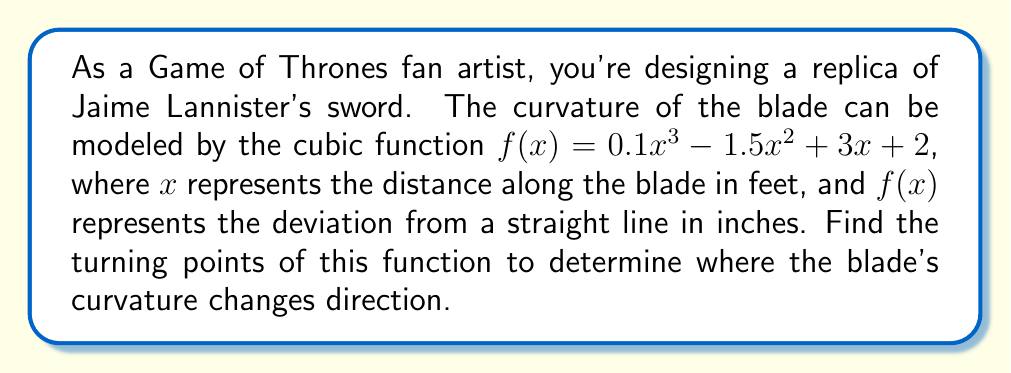What is the answer to this math problem? To find the turning points of a cubic function, we need to follow these steps:

1) The turning points occur where the derivative of the function is zero. Let's find the derivative:

   $f'(x) = 0.3x^2 - 3x + 3$

2) Set the derivative equal to zero and solve for x:

   $0.3x^2 - 3x + 3 = 0$

3) This is a quadratic equation. We can solve it using the quadratic formula:

   $x = \frac{-b \pm \sqrt{b^2 - 4ac}}{2a}$

   Where $a = 0.3$, $b = -3$, and $c = 3$

4) Substituting these values:

   $x = \frac{3 \pm \sqrt{(-3)^2 - 4(0.3)(3)}}{2(0.3)}$
   
   $x = \frac{3 \pm \sqrt{9 - 3.6}}{0.6}$
   
   $x = \frac{3 \pm \sqrt{5.4}}{0.6}$

5) Simplify:

   $x = \frac{3 \pm 2.32}{0.6}$

6) This gives us two solutions:

   $x_1 = \frac{3 + 2.32}{0.6} \approx 8.87$
   
   $x_2 = \frac{3 - 2.32}{0.6} \approx 1.13$

7) To find the y-coordinates, substitute these x-values back into the original function:

   For $x_1 = 8.87$:
   $f(8.87) = 0.1(8.87)^3 - 1.5(8.87)^2 + 3(8.87) + 2 \approx 13.04$

   For $x_2 = 1.13$:
   $f(1.13) = 0.1(1.13)^3 - 1.5(1.13)^2 + 3(1.13) + 2 \approx 3.69$

Therefore, the turning points are approximately (1.13, 3.69) and (8.87, 13.04).
Answer: The turning points of the function are approximately (1.13, 3.69) and (8.87, 13.04). 